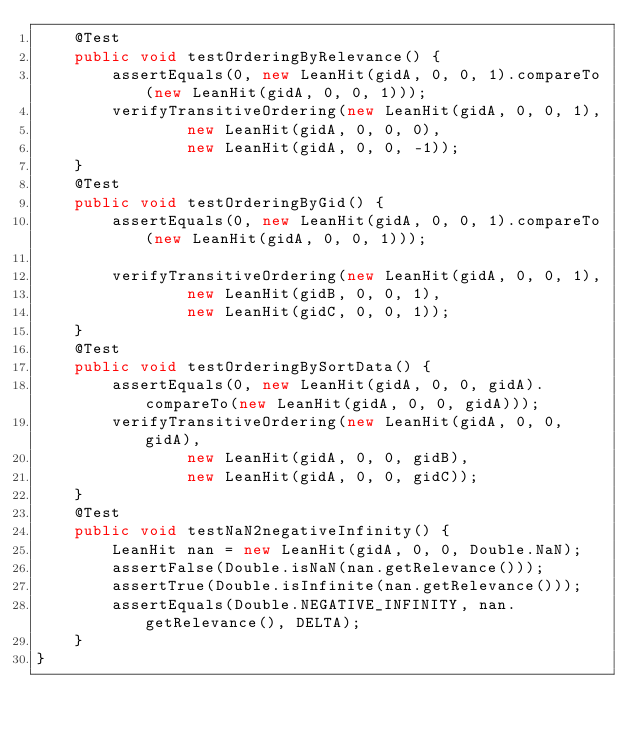<code> <loc_0><loc_0><loc_500><loc_500><_Java_>    @Test
    public void testOrderingByRelevance() {
        assertEquals(0, new LeanHit(gidA, 0, 0, 1).compareTo(new LeanHit(gidA, 0, 0, 1)));
        verifyTransitiveOrdering(new LeanHit(gidA, 0, 0, 1),
                new LeanHit(gidA, 0, 0, 0),
                new LeanHit(gidA, 0, 0, -1));
    }
    @Test
    public void testOrderingByGid() {
        assertEquals(0, new LeanHit(gidA, 0, 0, 1).compareTo(new LeanHit(gidA, 0, 0, 1)));

        verifyTransitiveOrdering(new LeanHit(gidA, 0, 0, 1),
                new LeanHit(gidB, 0, 0, 1),
                new LeanHit(gidC, 0, 0, 1));
    }
    @Test
    public void testOrderingBySortData() {
        assertEquals(0, new LeanHit(gidA, 0, 0, gidA).compareTo(new LeanHit(gidA, 0, 0, gidA)));
        verifyTransitiveOrdering(new LeanHit(gidA, 0, 0, gidA),
                new LeanHit(gidA, 0, 0, gidB),
                new LeanHit(gidA, 0, 0, gidC));
    }
    @Test
    public void testNaN2negativeInfinity() {
        LeanHit nan = new LeanHit(gidA, 0, 0, Double.NaN);
        assertFalse(Double.isNaN(nan.getRelevance()));
        assertTrue(Double.isInfinite(nan.getRelevance()));
        assertEquals(Double.NEGATIVE_INFINITY, nan.getRelevance(), DELTA);
    }
}
</code> 